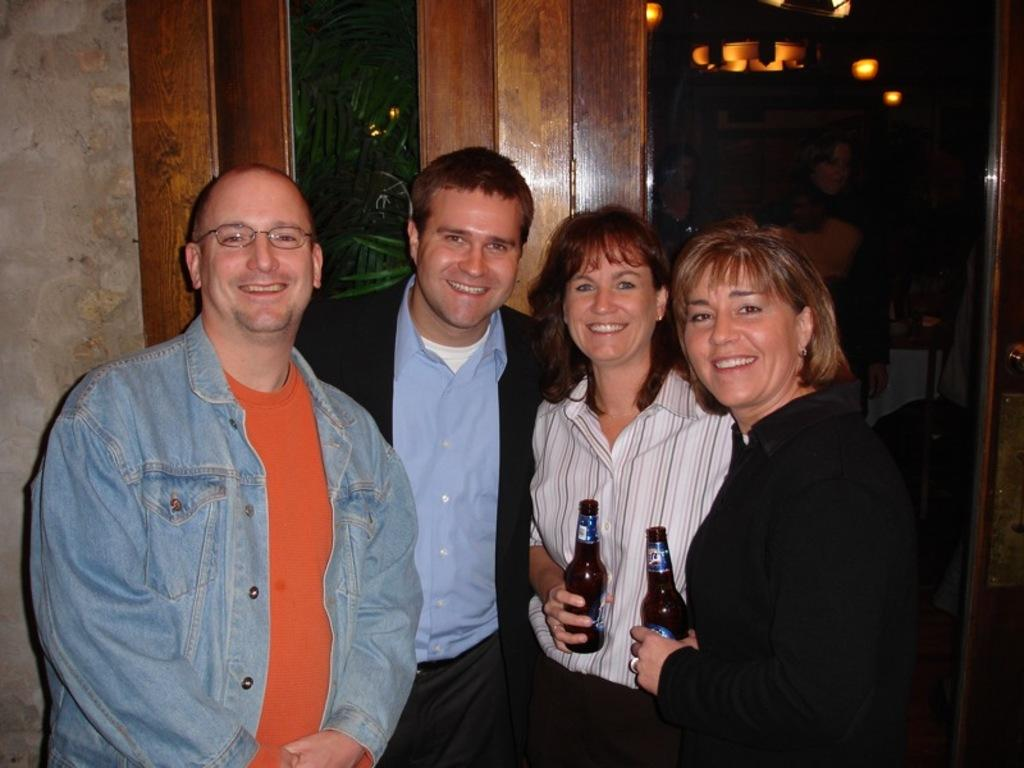What types of people are present in the image? There are men and women standing in the image. What are the women holding in the image? The women are holding a bottle in the image. Can you describe any architectural features in the image? Yes, there is a door in the image. What type of grass is growing in the image? There is no grass visible in the image. What day of the week is depicted in the image? The day of the week is not mentioned or depicted in the image. 